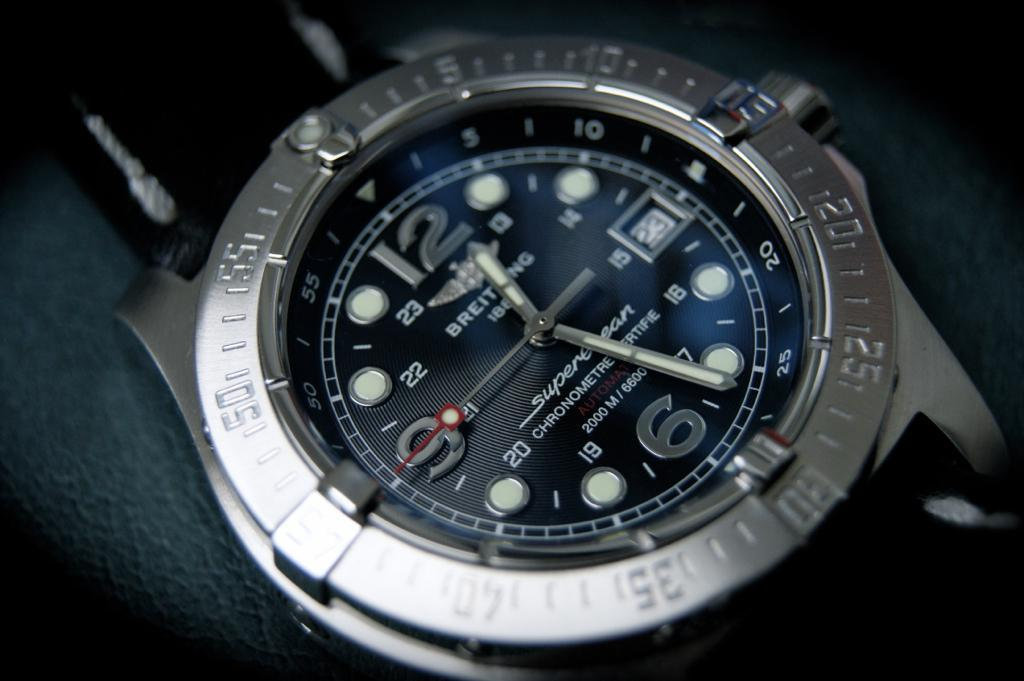<image>
Relay a brief, clear account of the picture shown. the face of a breit 188 super chronometre auto watch 